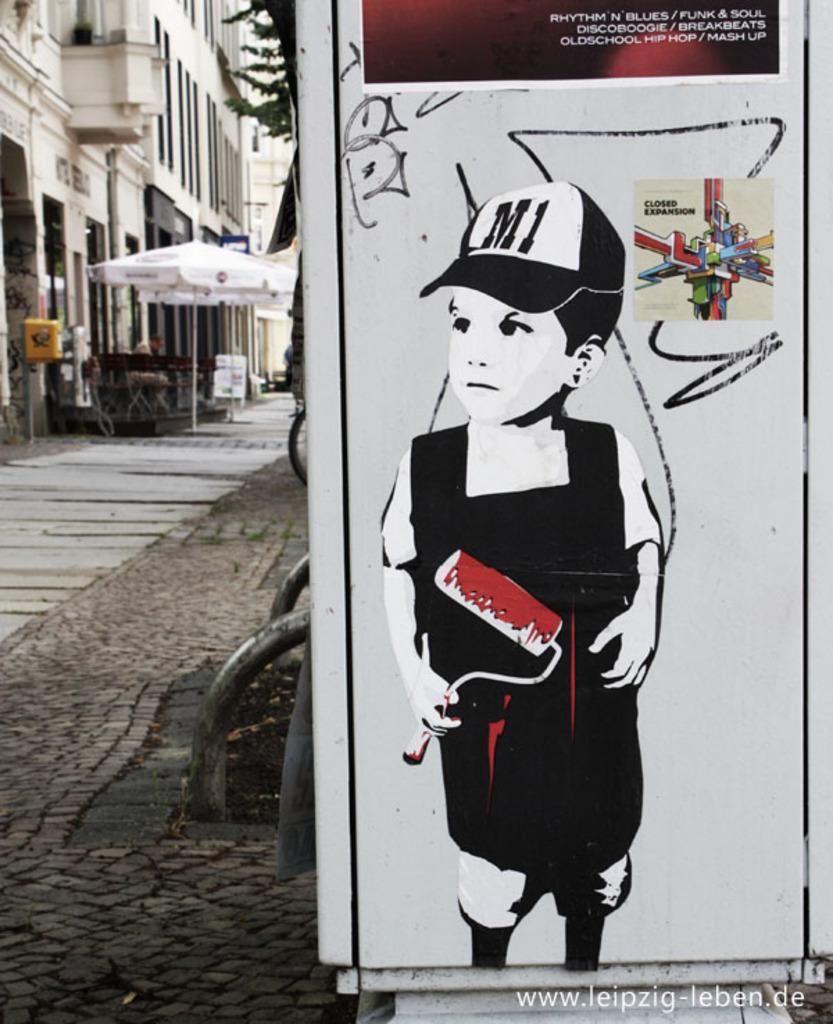In one or two sentences, can you explain what this image depicts? In the image we can see a poster, on it there is animated picture of a boy standing, wearing clothes, cap and the boy is holding a wall painting brush in hand. This is a footpath, umbrella and there are building. There is a tree and this is a watermark. 